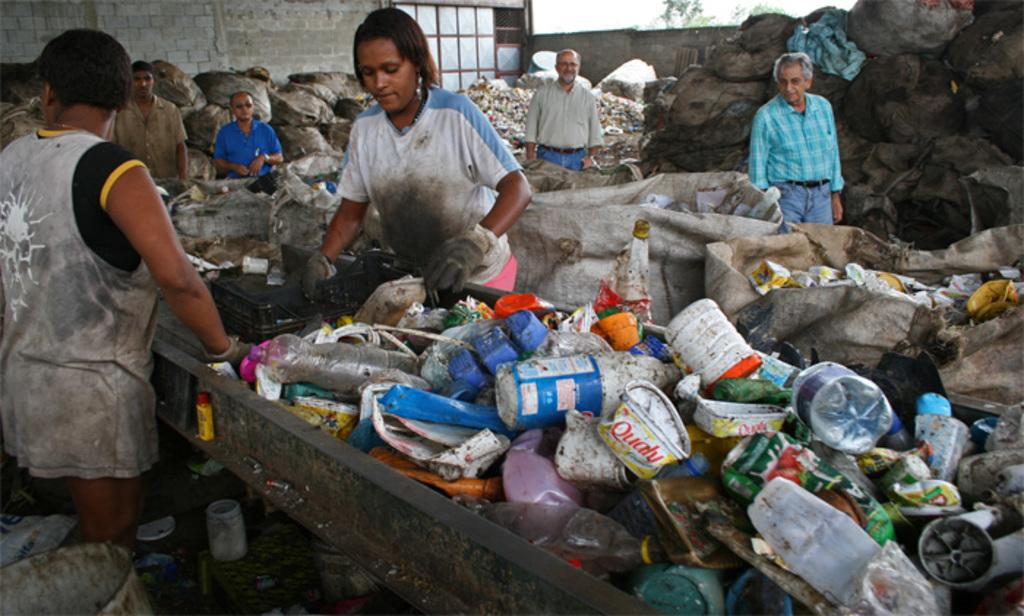What type of objects can be seen in the image? There are garbage materials in the image. Are there any people present in the image? Yes, there are people standing in the image. What can be seen in the background of the image? There is a wall and trees in the background of the image. How many kittens are playing with the machine in the image? There are no kittens or machines present in the image. What color is the cap worn by the person in the image? There is no person wearing a cap in the image. 